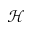Convert formula to latex. <formula><loc_0><loc_0><loc_500><loc_500>\mathcal { H }</formula> 